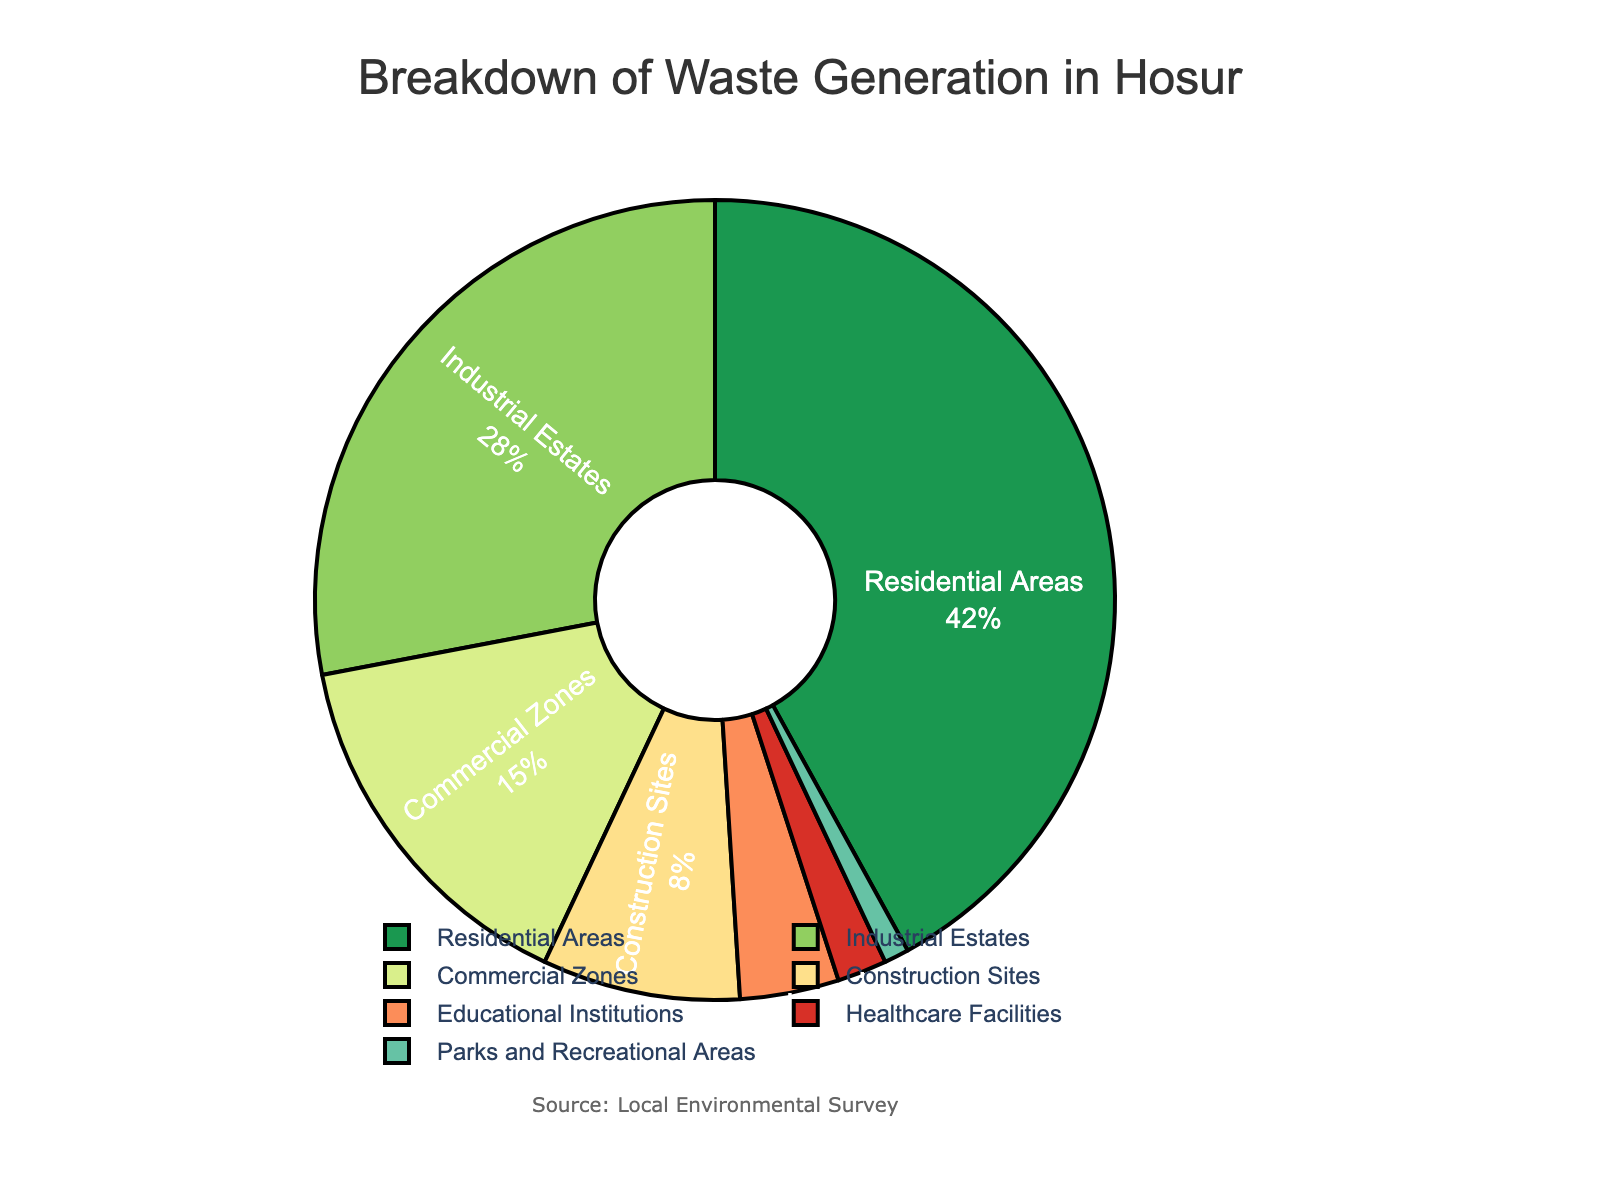Which waste source generates the highest percentage of waste in Hosur? The figure shows the percentage breakdown of waste generation by different sources. By looking at the pie chart, the segment with the largest percentage represents the highest waste source, which is "Residential Areas" with 42%.
Answer: Residential Areas Which waste sources combined contribute more than 50% of the total waste in Hosur? To find the sources that together contribute more than 50%, we start by adding the largest percentages: Residential Areas (42%) + Industrial Estates (28%) = 70%. This combined value is greater than 50%.
Answer: Residential Areas and Industrial Estates How does the waste percentage from healthcare facilities compare to that from educational institutions? Look at the percentages for Healthcare Facilities and Educational Institutions from the pie chart. Healthcare Facilities generate 2%, while Educational Institutions generate 4%. Therefore, Healthcare Facilities produce a lower percentage of waste.
Answer: Healthcare Facilities produce less waste than Educational Institutions If we combine waste percentages from construction sites and commercial zones, what's their total contribution? Add the waste percentages of Construction Sites (8%) and Commercial Zones (15%) from the pie chart: 8% + 15% = 23%. So, their total contribution is 23%.
Answer: 23% Which sector generates the least amount of waste, and what is its percentage? The segment with the smallest percentage of waste is identified by the smallest segment in the pie chart, which is "Parks and Recreational Areas" with 1%.
Answer: Parks and Recreational Areas, 1% What is the combined waste percentage from the three smallest contributing sectors? Identify the three smallest percentages from the pie chart: Parks and Recreational Areas (1%), Healthcare Facilities (2%), and Educational Institutions (4%). Summing these gives: 1% + 2% + 4% = 7%.
Answer: 7% How much more waste is generated by residential areas compared to industrial estates? From the pie chart, find the percentages for Residential Areas (42%) and Industrial Estates (28%). Subtract the latter from the former: 42% - 28% = 14%.
Answer: 14% Which color represents commercial zones in the pie chart? By looking at the pie chart and referring to its legend, the color associated with Commercial Zones is identified as a specific hue, which is "#fc8d59".
Answer: A shade of orange What percentage of waste is generated by non-residential areas? First, identify the residential areas' percentage (42%). Subtract this from 100% to find the percentage generated by non-residential sources: 100% - 42% = 58%.
Answer: 58% 